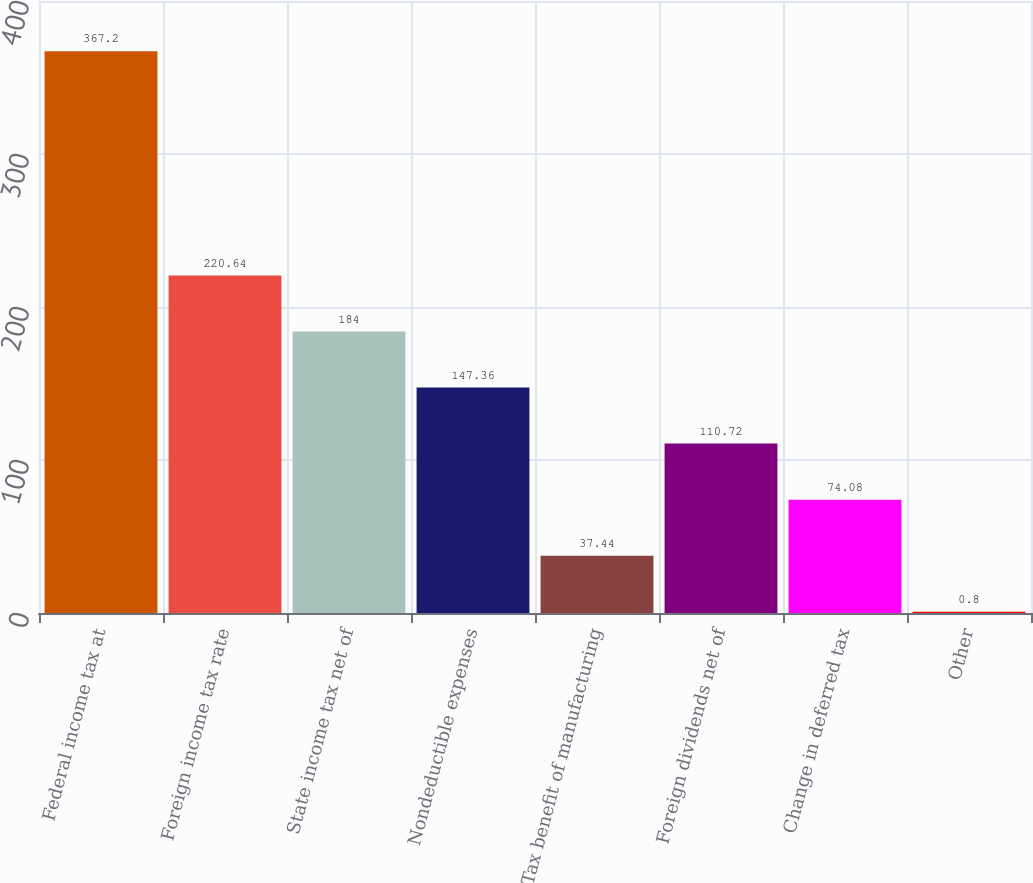<chart> <loc_0><loc_0><loc_500><loc_500><bar_chart><fcel>Federal income tax at<fcel>Foreign income tax rate<fcel>State income tax net of<fcel>Nondeductible expenses<fcel>Tax benefit of manufacturing<fcel>Foreign dividends net of<fcel>Change in deferred tax<fcel>Other<nl><fcel>367.2<fcel>220.64<fcel>184<fcel>147.36<fcel>37.44<fcel>110.72<fcel>74.08<fcel>0.8<nl></chart> 